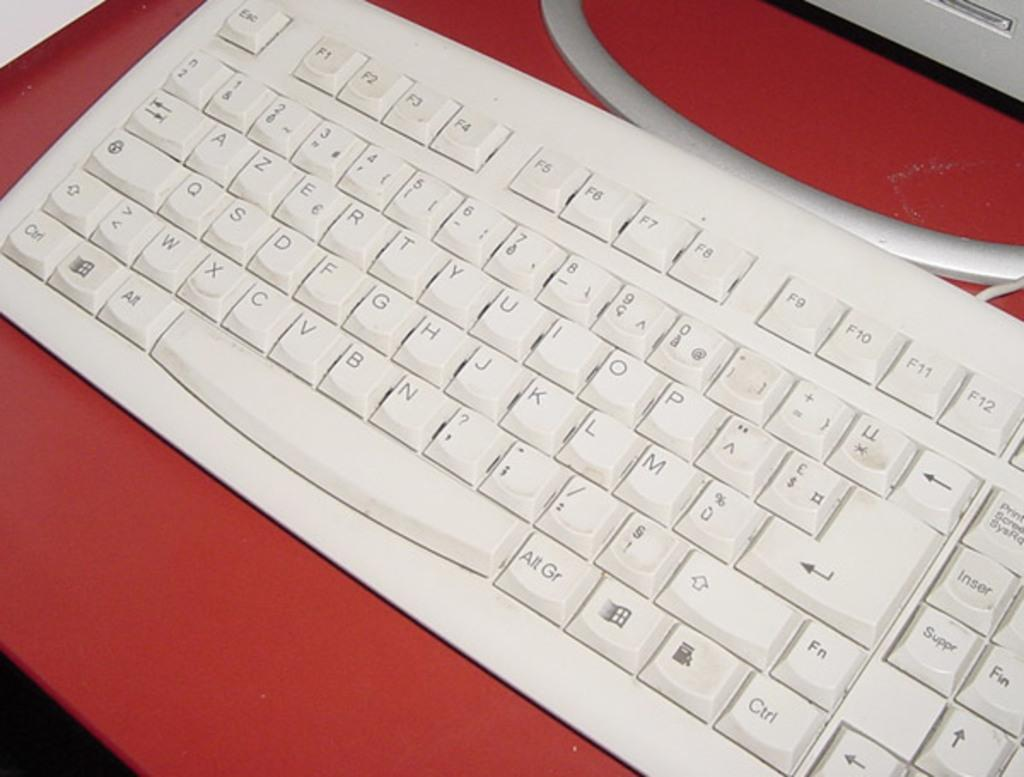<image>
Summarize the visual content of the image. A white keyboard has an Esc key at the top left. 